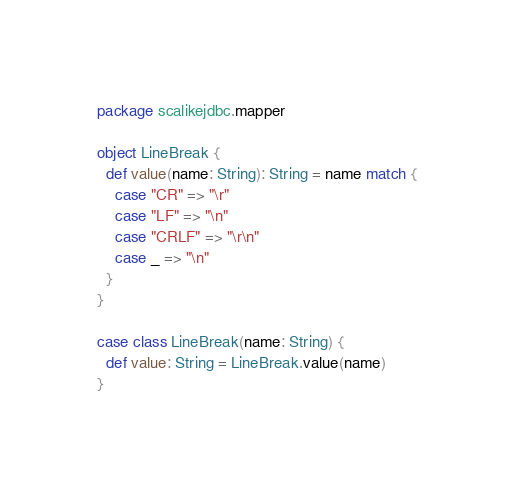<code> <loc_0><loc_0><loc_500><loc_500><_Scala_>package scalikejdbc.mapper

object LineBreak {
  def value(name: String): String = name match {
    case "CR" => "\r"
    case "LF" => "\n"
    case "CRLF" => "\r\n"
    case _ => "\n"
  }
}

case class LineBreak(name: String) {
  def value: String = LineBreak.value(name)
}
</code> 